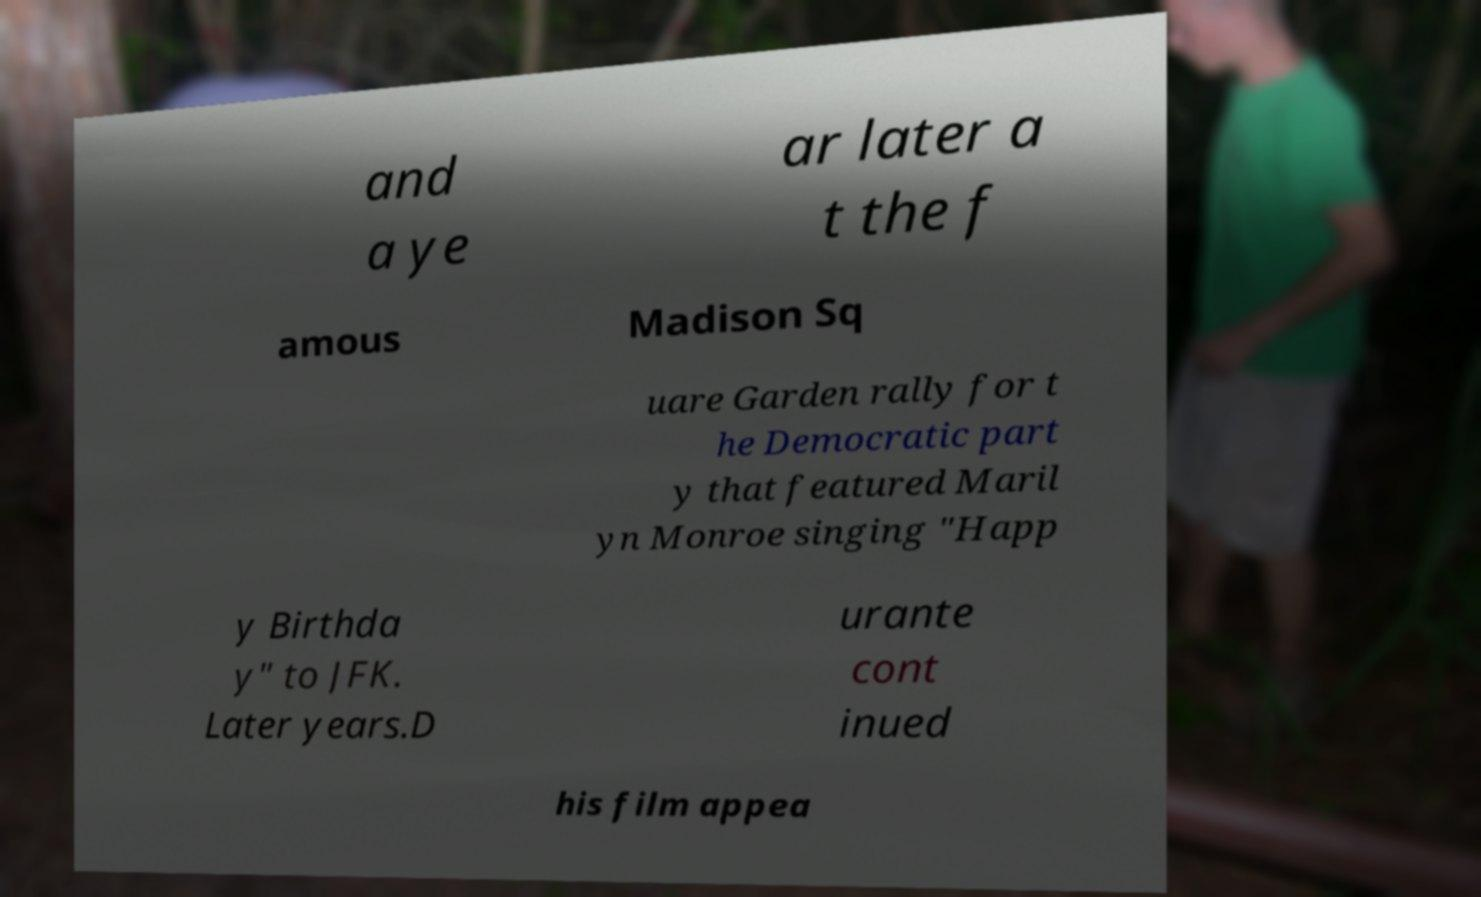Could you assist in decoding the text presented in this image and type it out clearly? and a ye ar later a t the f amous Madison Sq uare Garden rally for t he Democratic part y that featured Maril yn Monroe singing "Happ y Birthda y" to JFK. Later years.D urante cont inued his film appea 